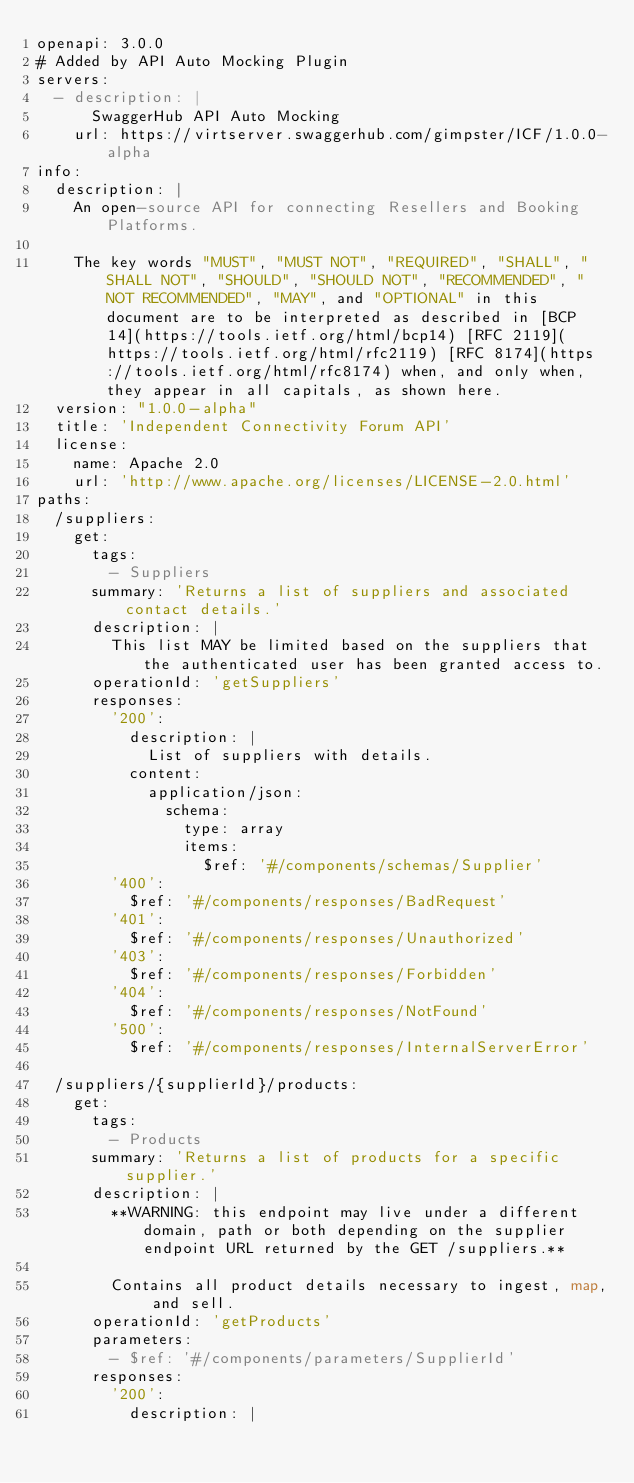Convert code to text. <code><loc_0><loc_0><loc_500><loc_500><_YAML_>openapi: 3.0.0
# Added by API Auto Mocking Plugin
servers:
  - description: |
      SwaggerHub API Auto Mocking
    url: https://virtserver.swaggerhub.com/gimpster/ICF/1.0.0-alpha
info:
  description: |
    An open-source API for connecting Resellers and Booking Platforms.

    The key words "MUST", "MUST NOT", "REQUIRED", "SHALL", "SHALL NOT", "SHOULD", "SHOULD NOT", "RECOMMENDED", "NOT RECOMMENDED", "MAY", and "OPTIONAL" in this document are to be interpreted as described in [BCP 14](https://tools.ietf.org/html/bcp14) [RFC 2119](https://tools.ietf.org/html/rfc2119) [RFC 8174](https://tools.ietf.org/html/rfc8174) when, and only when, they appear in all capitals, as shown here.
  version: "1.0.0-alpha"
  title: 'Independent Connectivity Forum API'
  license:
    name: Apache 2.0
    url: 'http://www.apache.org/licenses/LICENSE-2.0.html'
paths:
  /suppliers:
    get:
      tags:
        - Suppliers
      summary: 'Returns a list of suppliers and associated contact details.'
      description: |
        This list MAY be limited based on the suppliers that the authenticated user has been granted access to.
      operationId: 'getSuppliers'
      responses:
        '200':
          description: |
            List of suppliers with details.
          content:
            application/json:
              schema:
                type: array
                items:
                  $ref: '#/components/schemas/Supplier'
        '400':
          $ref: '#/components/responses/BadRequest'
        '401':
          $ref: '#/components/responses/Unauthorized'
        '403':
          $ref: '#/components/responses/Forbidden'
        '404':
          $ref: '#/components/responses/NotFound'
        '500':
          $ref: '#/components/responses/InternalServerError'

  /suppliers/{supplierId}/products:
    get:
      tags:
        - Products
      summary: 'Returns a list of products for a specific supplier.'
      description: |
        **WARNING: this endpoint may live under a different domain, path or both depending on the supplier endpoint URL returned by the GET /suppliers.**

        Contains all product details necessary to ingest, map, and sell.
      operationId: 'getProducts'
      parameters:
        - $ref: '#/components/parameters/SupplierId'
      responses:
        '200':
          description: |</code> 